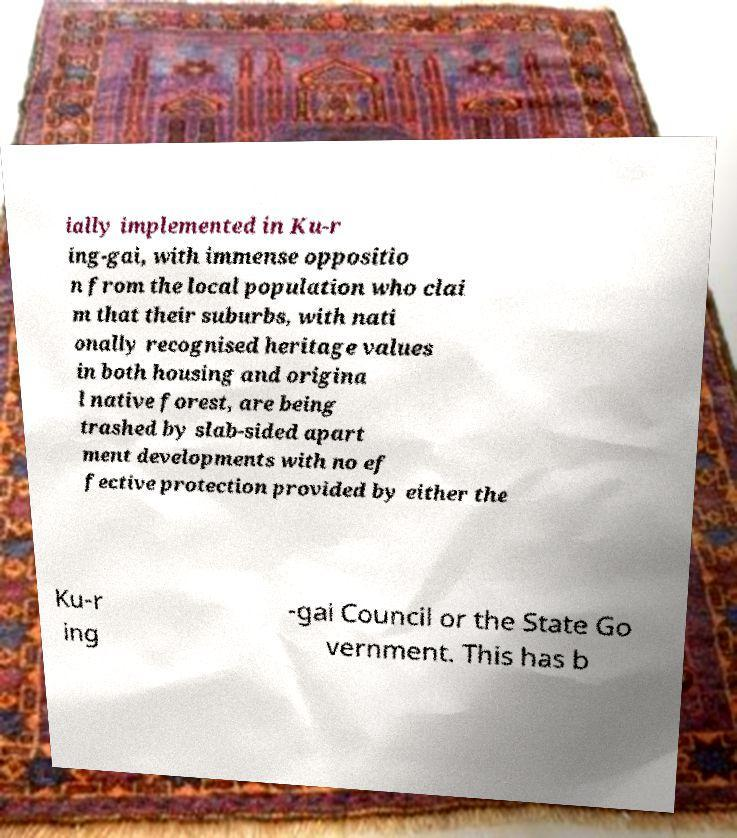There's text embedded in this image that I need extracted. Can you transcribe it verbatim? ially implemented in Ku-r ing-gai, with immense oppositio n from the local population who clai m that their suburbs, with nati onally recognised heritage values in both housing and origina l native forest, are being trashed by slab-sided apart ment developments with no ef fective protection provided by either the Ku-r ing -gai Council or the State Go vernment. This has b 